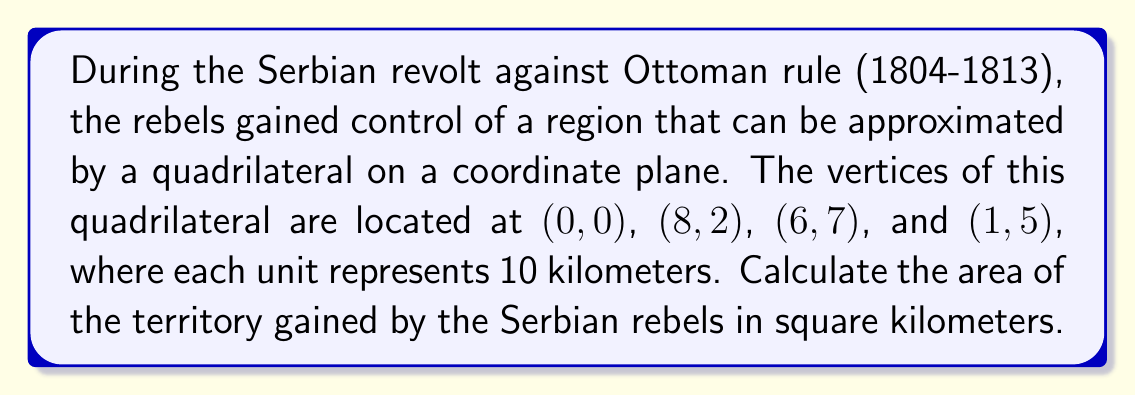Could you help me with this problem? To solve this problem, we'll use the Shoelace formula (also known as the surveyor's formula) to calculate the area of the quadrilateral. The steps are as follows:

1) The Shoelace formula for a quadrilateral with vertices $(x_1, y_1)$, $(x_2, y_2)$, $(x_3, y_3)$, and $(x_4, y_4)$ is:

   $$A = \frac{1}{2}|(x_1y_2 + x_2y_3 + x_3y_4 + x_4y_1) - (y_1x_2 + y_2x_3 + y_3x_4 + y_4x_1)|$$

2) Let's assign our vertices:
   $(x_1, y_1) = (0, 0)$
   $(x_2, y_2) = (8, 2)$
   $(x_3, y_3) = (6, 7)$
   $(x_4, y_4) = (1, 5)$

3) Now, let's substitute these into the formula:

   $$A = \frac{1}{2}|(0 \cdot 2 + 8 \cdot 7 + 6 \cdot 5 + 1 \cdot 0) - (0 \cdot 8 + 2 \cdot 6 + 7 \cdot 1 + 5 \cdot 0)|$$

4) Simplify:

   $$A = \frac{1}{2}|(0 + 56 + 30 + 0) - (0 + 12 + 7 + 0)|$$
   $$A = \frac{1}{2}|86 - 19|$$
   $$A = \frac{1}{2}(67)$$
   $$A = 33.5$$

5) Remember that each unit represents 10 kilometers. To get the area in square kilometers, we need to multiply by $10^2 = 100$:

   $$\text{Area} = 33.5 \cdot 100 = 3350 \text{ km}^2$$

Therefore, the area of the territory gained by the Serbian rebels is 3350 square kilometers.
Answer: 3350 square kilometers 